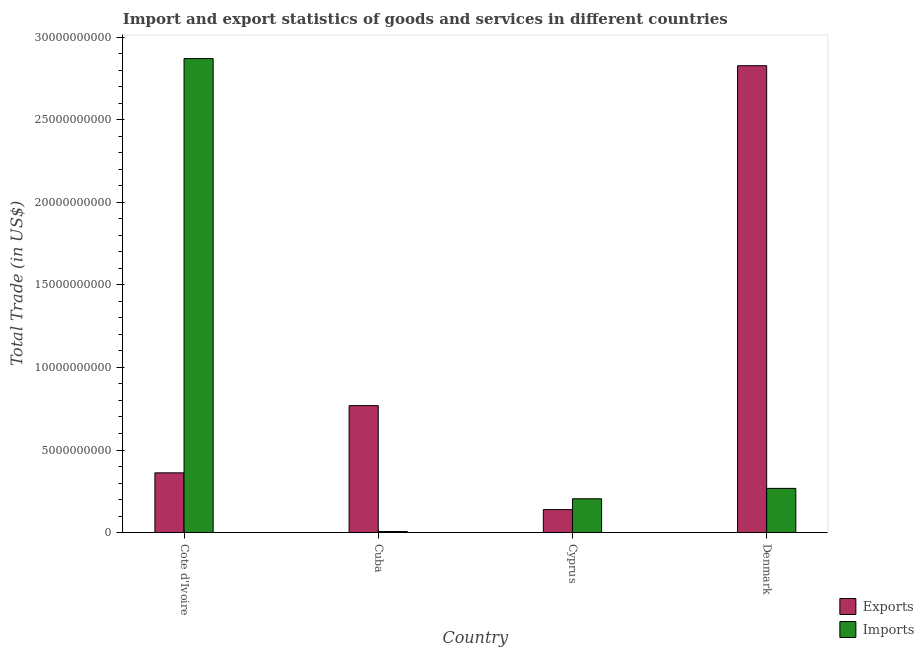How many groups of bars are there?
Keep it short and to the point. 4. Are the number of bars on each tick of the X-axis equal?
Your response must be concise. Yes. How many bars are there on the 4th tick from the right?
Provide a short and direct response. 2. What is the label of the 4th group of bars from the left?
Provide a short and direct response. Denmark. In how many cases, is the number of bars for a given country not equal to the number of legend labels?
Keep it short and to the point. 0. What is the export of goods and services in Cote d'Ivoire?
Ensure brevity in your answer.  3.62e+09. Across all countries, what is the maximum export of goods and services?
Offer a very short reply. 2.83e+1. Across all countries, what is the minimum export of goods and services?
Provide a succinct answer. 1.39e+09. In which country was the imports of goods and services maximum?
Offer a terse response. Cote d'Ivoire. In which country was the export of goods and services minimum?
Provide a succinct answer. Cyprus. What is the total export of goods and services in the graph?
Offer a very short reply. 4.10e+1. What is the difference between the imports of goods and services in Cote d'Ivoire and that in Cuba?
Your response must be concise. 2.86e+1. What is the difference between the imports of goods and services in Denmark and the export of goods and services in Cuba?
Your answer should be compact. -5.01e+09. What is the average imports of goods and services per country?
Give a very brief answer. 8.37e+09. What is the difference between the export of goods and services and imports of goods and services in Denmark?
Give a very brief answer. 2.56e+1. What is the ratio of the export of goods and services in Cote d'Ivoire to that in Denmark?
Your answer should be compact. 0.13. What is the difference between the highest and the second highest imports of goods and services?
Make the answer very short. 2.60e+1. What is the difference between the highest and the lowest export of goods and services?
Provide a short and direct response. 2.69e+1. In how many countries, is the export of goods and services greater than the average export of goods and services taken over all countries?
Your response must be concise. 1. What does the 1st bar from the left in Cyprus represents?
Provide a short and direct response. Exports. What does the 2nd bar from the right in Cuba represents?
Make the answer very short. Exports. How many bars are there?
Keep it short and to the point. 8. Does the graph contain any zero values?
Provide a short and direct response. No. Does the graph contain grids?
Your answer should be compact. No. Where does the legend appear in the graph?
Offer a terse response. Bottom right. How are the legend labels stacked?
Your answer should be compact. Vertical. What is the title of the graph?
Offer a terse response. Import and export statistics of goods and services in different countries. Does "Under-5(male)" appear as one of the legend labels in the graph?
Provide a succinct answer. No. What is the label or title of the Y-axis?
Your response must be concise. Total Trade (in US$). What is the Total Trade (in US$) of Exports in Cote d'Ivoire?
Your answer should be very brief. 3.62e+09. What is the Total Trade (in US$) of Imports in Cote d'Ivoire?
Your answer should be very brief. 2.87e+1. What is the Total Trade (in US$) in Exports in Cuba?
Keep it short and to the point. 7.69e+09. What is the Total Trade (in US$) of Imports in Cuba?
Keep it short and to the point. 6.64e+07. What is the Total Trade (in US$) of Exports in Cyprus?
Keep it short and to the point. 1.39e+09. What is the Total Trade (in US$) of Imports in Cyprus?
Give a very brief answer. 2.05e+09. What is the Total Trade (in US$) of Exports in Denmark?
Ensure brevity in your answer.  2.83e+1. What is the Total Trade (in US$) in Imports in Denmark?
Offer a very short reply. 2.68e+09. Across all countries, what is the maximum Total Trade (in US$) of Exports?
Give a very brief answer. 2.83e+1. Across all countries, what is the maximum Total Trade (in US$) in Imports?
Offer a terse response. 2.87e+1. Across all countries, what is the minimum Total Trade (in US$) in Exports?
Offer a terse response. 1.39e+09. Across all countries, what is the minimum Total Trade (in US$) of Imports?
Your response must be concise. 6.64e+07. What is the total Total Trade (in US$) of Exports in the graph?
Give a very brief answer. 4.10e+1. What is the total Total Trade (in US$) of Imports in the graph?
Provide a short and direct response. 3.35e+1. What is the difference between the Total Trade (in US$) of Exports in Cote d'Ivoire and that in Cuba?
Offer a very short reply. -4.07e+09. What is the difference between the Total Trade (in US$) of Imports in Cote d'Ivoire and that in Cuba?
Provide a succinct answer. 2.86e+1. What is the difference between the Total Trade (in US$) in Exports in Cote d'Ivoire and that in Cyprus?
Your answer should be compact. 2.23e+09. What is the difference between the Total Trade (in US$) in Imports in Cote d'Ivoire and that in Cyprus?
Ensure brevity in your answer.  2.67e+1. What is the difference between the Total Trade (in US$) of Exports in Cote d'Ivoire and that in Denmark?
Offer a very short reply. -2.47e+1. What is the difference between the Total Trade (in US$) in Imports in Cote d'Ivoire and that in Denmark?
Your answer should be compact. 2.60e+1. What is the difference between the Total Trade (in US$) in Exports in Cuba and that in Cyprus?
Provide a succinct answer. 6.30e+09. What is the difference between the Total Trade (in US$) of Imports in Cuba and that in Cyprus?
Your answer should be very brief. -1.98e+09. What is the difference between the Total Trade (in US$) in Exports in Cuba and that in Denmark?
Your response must be concise. -2.06e+1. What is the difference between the Total Trade (in US$) in Imports in Cuba and that in Denmark?
Offer a very short reply. -2.61e+09. What is the difference between the Total Trade (in US$) of Exports in Cyprus and that in Denmark?
Make the answer very short. -2.69e+1. What is the difference between the Total Trade (in US$) in Imports in Cyprus and that in Denmark?
Offer a terse response. -6.28e+08. What is the difference between the Total Trade (in US$) in Exports in Cote d'Ivoire and the Total Trade (in US$) in Imports in Cuba?
Offer a very short reply. 3.55e+09. What is the difference between the Total Trade (in US$) in Exports in Cote d'Ivoire and the Total Trade (in US$) in Imports in Cyprus?
Provide a succinct answer. 1.57e+09. What is the difference between the Total Trade (in US$) in Exports in Cote d'Ivoire and the Total Trade (in US$) in Imports in Denmark?
Ensure brevity in your answer.  9.40e+08. What is the difference between the Total Trade (in US$) in Exports in Cuba and the Total Trade (in US$) in Imports in Cyprus?
Your response must be concise. 5.64e+09. What is the difference between the Total Trade (in US$) in Exports in Cuba and the Total Trade (in US$) in Imports in Denmark?
Make the answer very short. 5.01e+09. What is the difference between the Total Trade (in US$) in Exports in Cyprus and the Total Trade (in US$) in Imports in Denmark?
Your answer should be very brief. -1.29e+09. What is the average Total Trade (in US$) of Exports per country?
Make the answer very short. 1.02e+1. What is the average Total Trade (in US$) in Imports per country?
Ensure brevity in your answer.  8.37e+09. What is the difference between the Total Trade (in US$) in Exports and Total Trade (in US$) in Imports in Cote d'Ivoire?
Give a very brief answer. -2.51e+1. What is the difference between the Total Trade (in US$) in Exports and Total Trade (in US$) in Imports in Cuba?
Your response must be concise. 7.62e+09. What is the difference between the Total Trade (in US$) of Exports and Total Trade (in US$) of Imports in Cyprus?
Offer a very short reply. -6.57e+08. What is the difference between the Total Trade (in US$) in Exports and Total Trade (in US$) in Imports in Denmark?
Keep it short and to the point. 2.56e+1. What is the ratio of the Total Trade (in US$) of Exports in Cote d'Ivoire to that in Cuba?
Provide a short and direct response. 0.47. What is the ratio of the Total Trade (in US$) of Imports in Cote d'Ivoire to that in Cuba?
Provide a succinct answer. 432.46. What is the ratio of the Total Trade (in US$) in Exports in Cote d'Ivoire to that in Cyprus?
Offer a terse response. 2.6. What is the ratio of the Total Trade (in US$) in Imports in Cote d'Ivoire to that in Cyprus?
Your answer should be compact. 14.01. What is the ratio of the Total Trade (in US$) of Exports in Cote d'Ivoire to that in Denmark?
Keep it short and to the point. 0.13. What is the ratio of the Total Trade (in US$) of Imports in Cote d'Ivoire to that in Denmark?
Offer a terse response. 10.72. What is the ratio of the Total Trade (in US$) in Exports in Cuba to that in Cyprus?
Ensure brevity in your answer.  5.52. What is the ratio of the Total Trade (in US$) of Imports in Cuba to that in Cyprus?
Make the answer very short. 0.03. What is the ratio of the Total Trade (in US$) of Exports in Cuba to that in Denmark?
Your response must be concise. 0.27. What is the ratio of the Total Trade (in US$) in Imports in Cuba to that in Denmark?
Make the answer very short. 0.02. What is the ratio of the Total Trade (in US$) of Exports in Cyprus to that in Denmark?
Your answer should be compact. 0.05. What is the ratio of the Total Trade (in US$) in Imports in Cyprus to that in Denmark?
Your answer should be compact. 0.77. What is the difference between the highest and the second highest Total Trade (in US$) of Exports?
Provide a succinct answer. 2.06e+1. What is the difference between the highest and the second highest Total Trade (in US$) of Imports?
Provide a short and direct response. 2.60e+1. What is the difference between the highest and the lowest Total Trade (in US$) of Exports?
Your answer should be compact. 2.69e+1. What is the difference between the highest and the lowest Total Trade (in US$) in Imports?
Offer a terse response. 2.86e+1. 